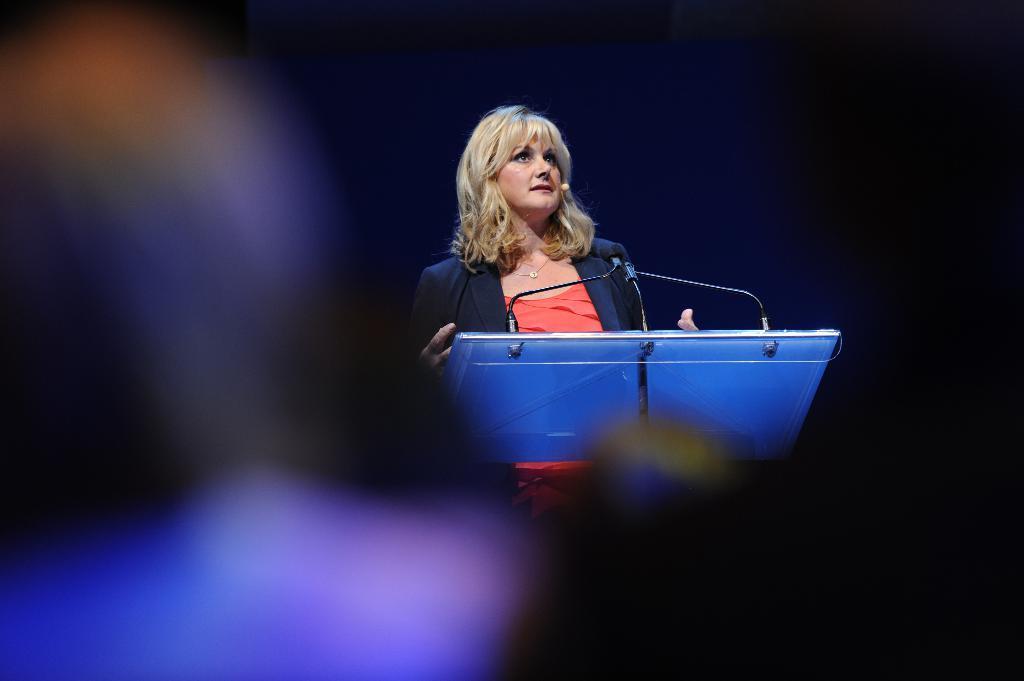In one or two sentences, can you explain what this image depicts? A beautiful is speaking in the microphone, she wore orange color t-shirt and black color coat. 